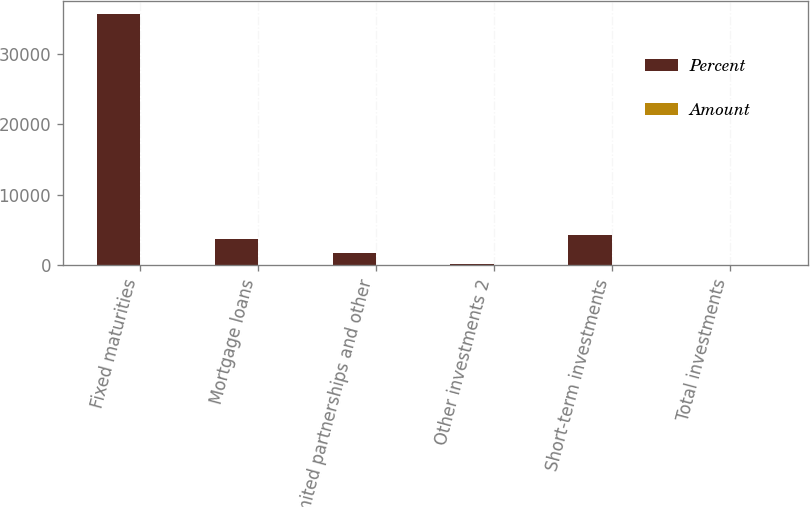Convert chart. <chart><loc_0><loc_0><loc_500><loc_500><stacked_bar_chart><ecel><fcel>Fixed maturities<fcel>Mortgage loans<fcel>Limited partnerships and other<fcel>Other investments 2<fcel>Short-term investments<fcel>Total investments<nl><fcel>Percent<fcel>35652<fcel>3704<fcel>1723<fcel>192<fcel>4283<fcel>100<nl><fcel>Amount<fcel>76.2<fcel>7.9<fcel>3.7<fcel>0.4<fcel>9.2<fcel>100<nl></chart> 